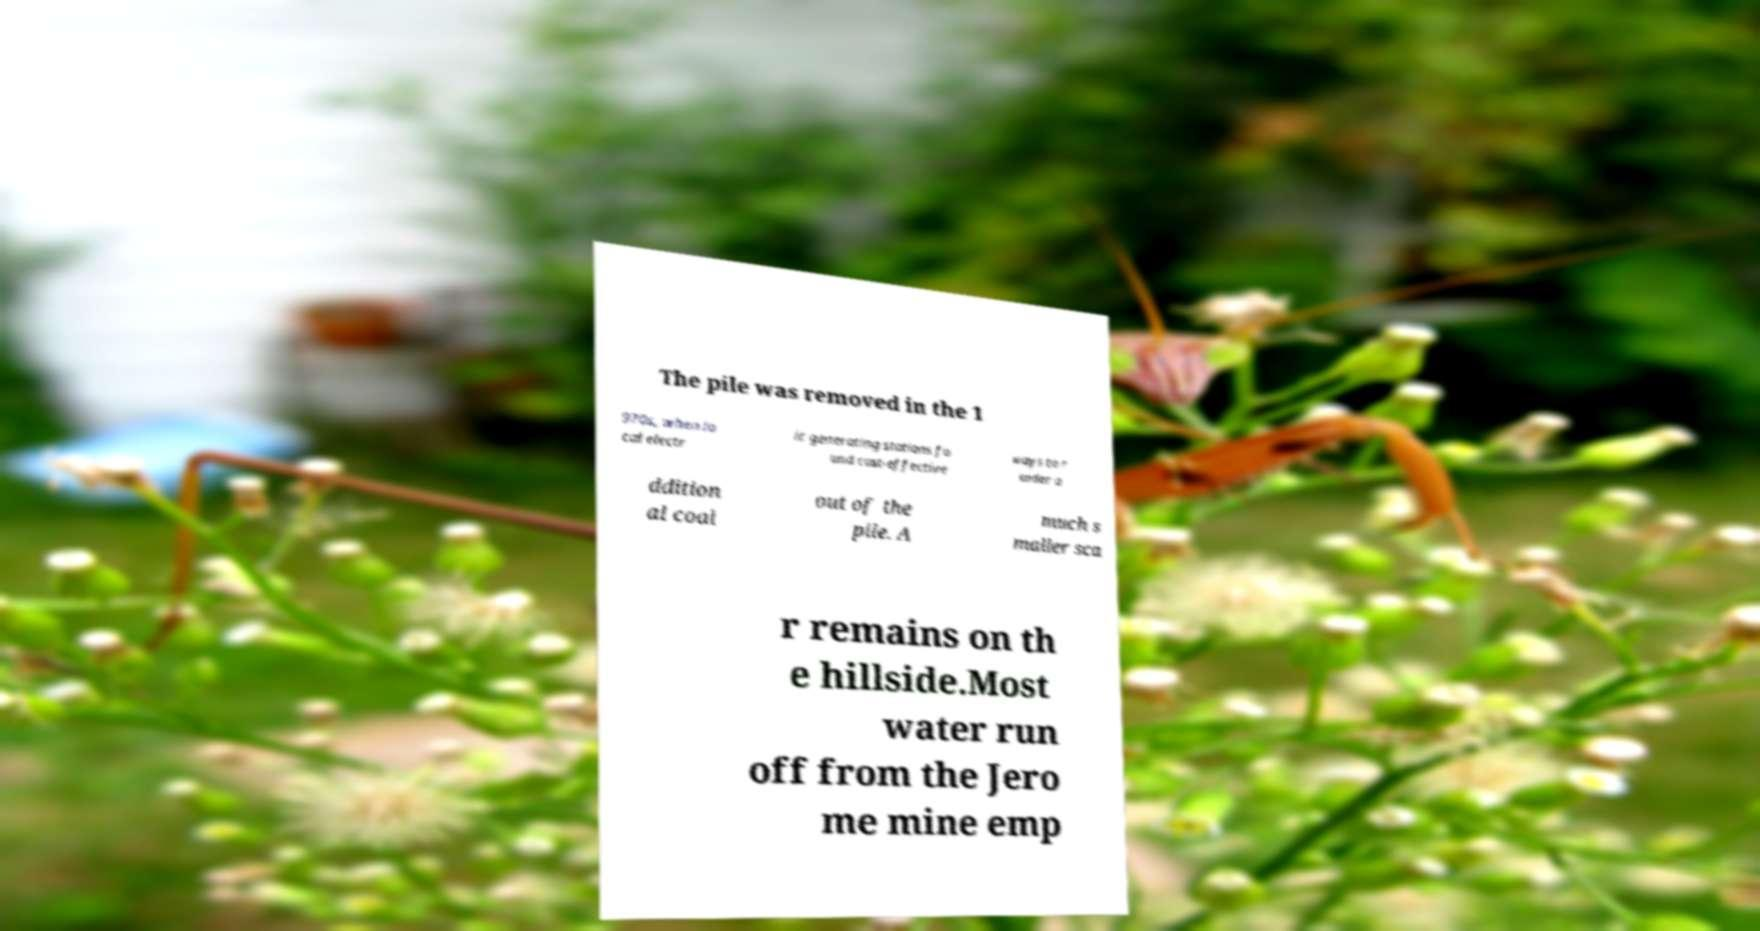What messages or text are displayed in this image? I need them in a readable, typed format. The pile was removed in the 1 970s, when lo cal electr ic generating stations fo und cost-effective ways to r ender a ddition al coal out of the pile. A much s maller sca r remains on th e hillside.Most water run off from the Jero me mine emp 